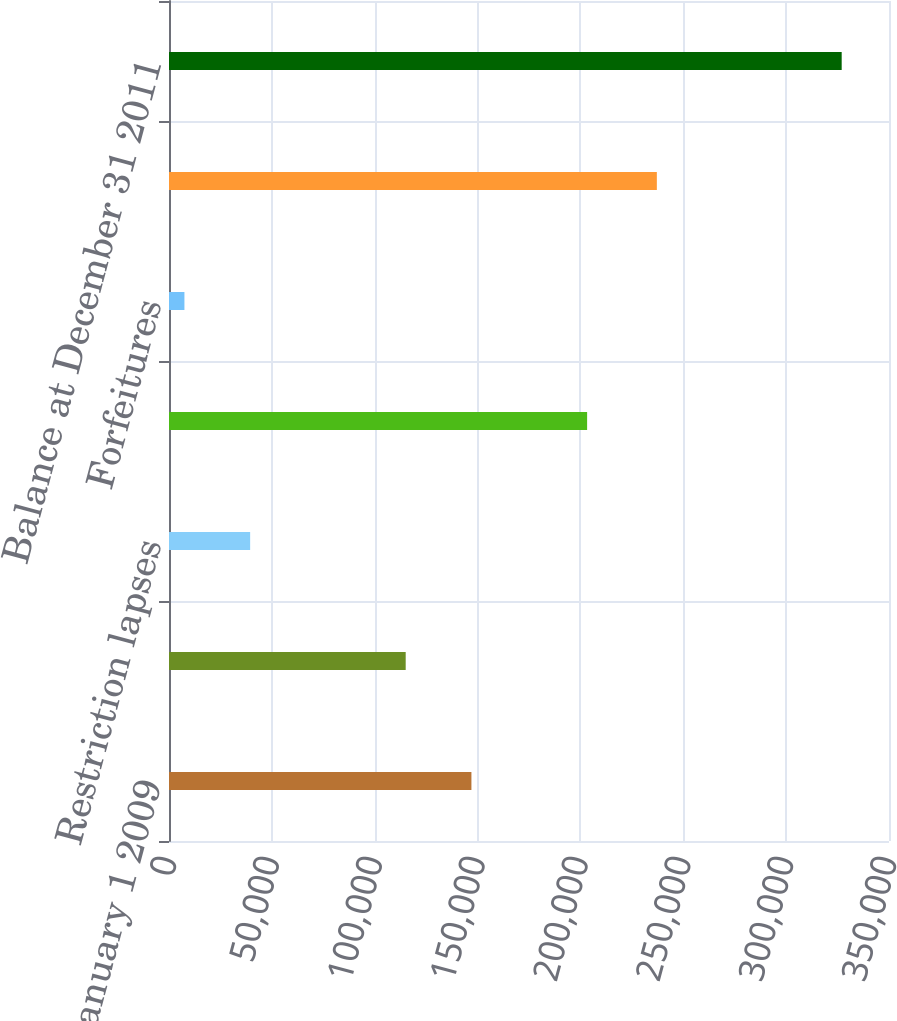Convert chart to OTSL. <chart><loc_0><loc_0><loc_500><loc_500><bar_chart><fcel>Balance at January 1 2009<fcel>Grants<fcel>Restriction lapses<fcel>Balance at December 31 2009<fcel>Forfeitures<fcel>Balance at December 31 2010<fcel>Balance at December 31 2011<nl><fcel>147010<fcel>115060<fcel>39450<fcel>203250<fcel>7500<fcel>237150<fcel>327000<nl></chart> 